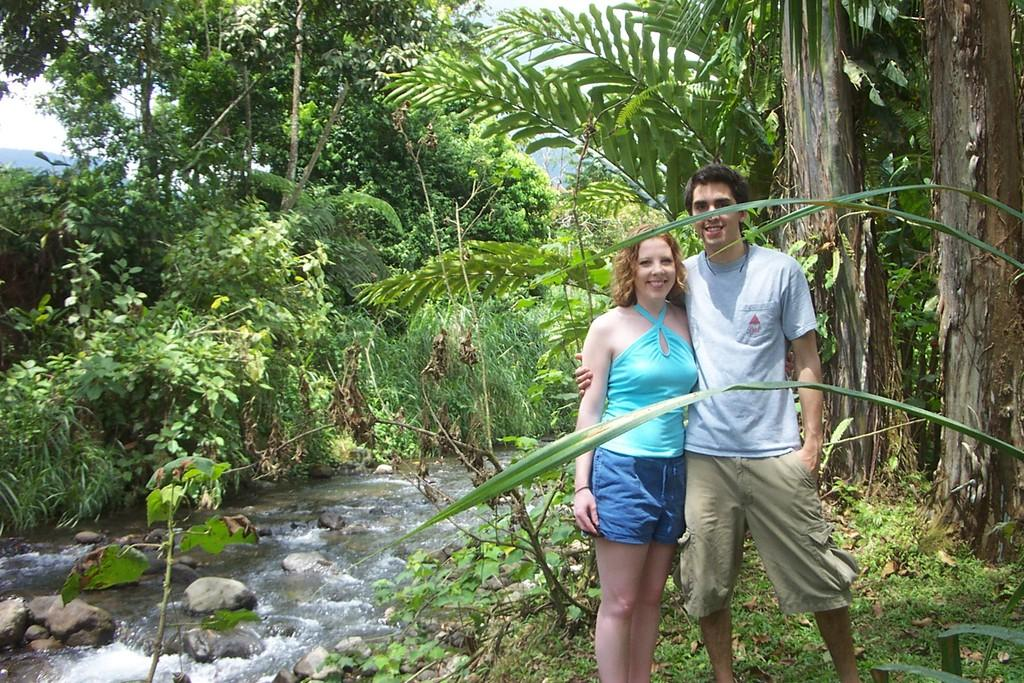How many people are in the image? There is a man and a woman in the image. What are the expressions on their faces? Both the man and woman are smiling. What can be seen in the background of the image? There are trees visible in the image. What is happening with the water in the image? Water is flowing in the image. What is present in the water? There are stones in the water. What type of ground is visible in the image? Grass is present on the ground. Is the farmer in the image taking a quiet vacation? There is no farmer or mention of a vacation in the image. The image features a man and a woman who are smiling, along with trees, water, stones, and grass. 